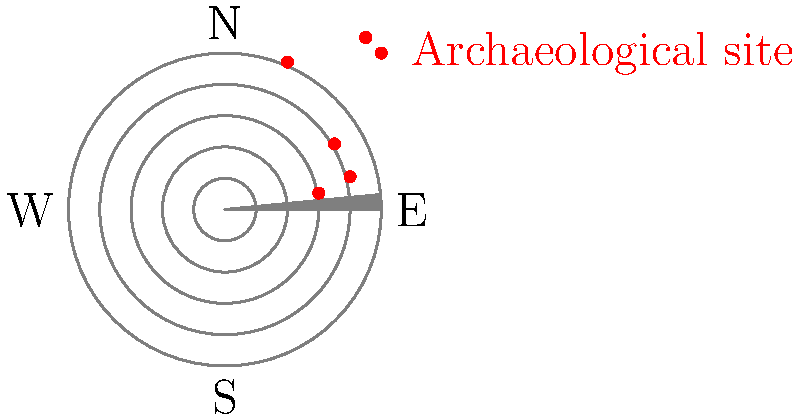A team of archaeologists has discovered five ancient settlement sites in a circular region. The sites are plotted on a polar grid, where the distance from the center represents the age of the site (in thousands of years), and the angle represents the direction from a central reference point. If the oldest site is located at $(r,\theta) = (4.5, \frac{7\pi}{4})$, what is the average age of all five sites, rounded to the nearest hundred years? To solve this problem, we need to follow these steps:

1. Identify the r-coordinates (radii) of all five sites from the polar plot:
   Site 1: $r_1 = 3$
   Site 2: $r_2 = 4$
   Site 3: $r_3 = 2$
   Site 4: $r_4 = 4.5$
   Site 5: $r_5 = 3.5$

2. Recall that in this plot, the r-coordinate represents the age of the site in thousands of years.

3. Calculate the sum of all ages:
   $\text{Sum} = 3 + 4 + 2 + 4.5 + 3.5 = 17$ thousand years

4. Calculate the average age:
   $\text{Average} = \frac{\text{Sum}}{\text{Number of sites}} = \frac{17}{5} = 3.4$ thousand years

5. Convert the average to years:
   $3.4 \times 1000 = 3400$ years

6. Round to the nearest hundred years:
   $3400$ rounded to the nearest hundred is $3400$ years

Therefore, the average age of all five sites, rounded to the nearest hundred years, is 3400 years.
Answer: 3400 years 